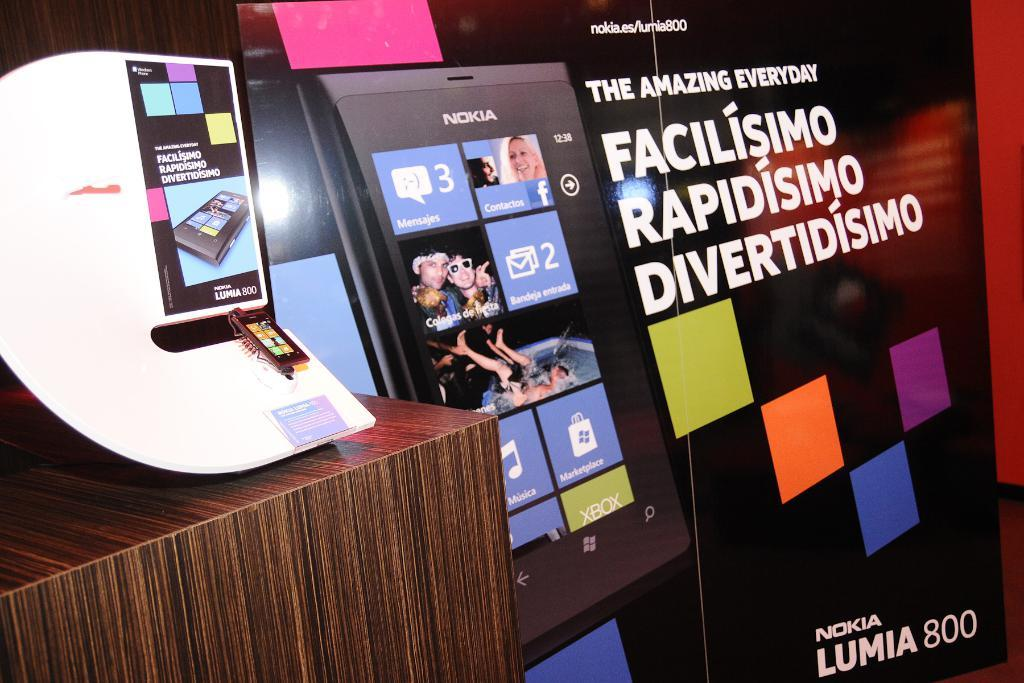<image>
Render a clear and concise summary of the photo. An ad for a phone called the nokia lumia 800 